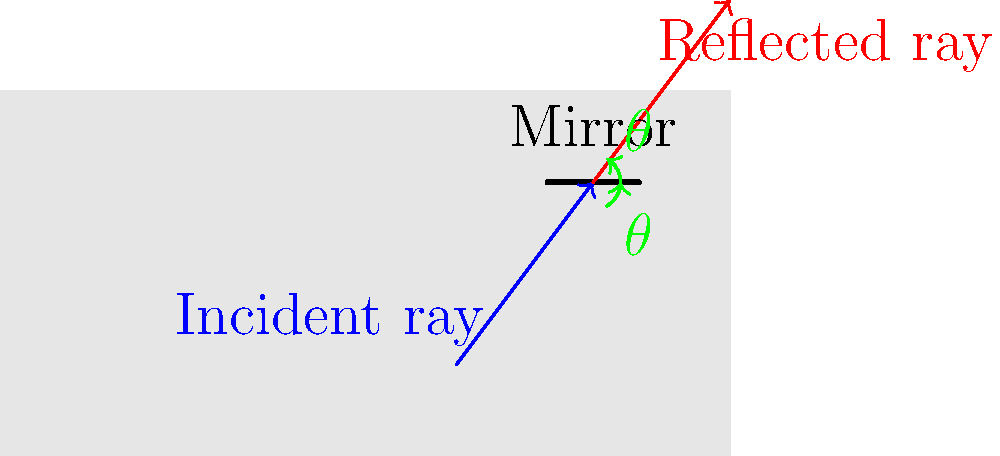As a taxi driver, you rely on your rearview mirror to see vehicles behind you. If a car's headlights are reflected off your rearview mirror at the same angle as they hit the mirror, what is this phenomenon called, and what is the relationship between the angle of incidence ($\theta_i$) and the angle of reflection ($\theta_r$)? Let's break this down step-by-step:

1. The phenomenon described is known as the law of reflection. This fundamental principle in optics governs how light behaves when it encounters a reflective surface.

2. The law of reflection states that:
   a) The incident ray, the reflected ray, and the normal to the surface at the point of incidence all lie in the same plane.
   b) The angle of incidence ($\theta_i$) is equal to the angle of reflection ($\theta_r$).

3. In the context of your taxi's rearview mirror:
   - The incident ray is the light from the car's headlights hitting your mirror.
   - The reflected ray is the light bouncing off your mirror into your eyes.
   - The normal is an imaginary line perpendicular to the mirror's surface at the point where the light hits.

4. Mathematically, this relationship is expressed as:

   $$\theta_i = \theta_r$$

5. This equality ensures that the light from objects behind your taxi is accurately reflected to your eyes, allowing you to see them clearly in your rearview mirror.

6. Understanding this principle is crucial for safe driving, as it explains why you can see vehicles behind you without turning around, and why adjusting your mirror's angle changes what you can see.
Answer: Law of reflection; $\theta_i = \theta_r$ 